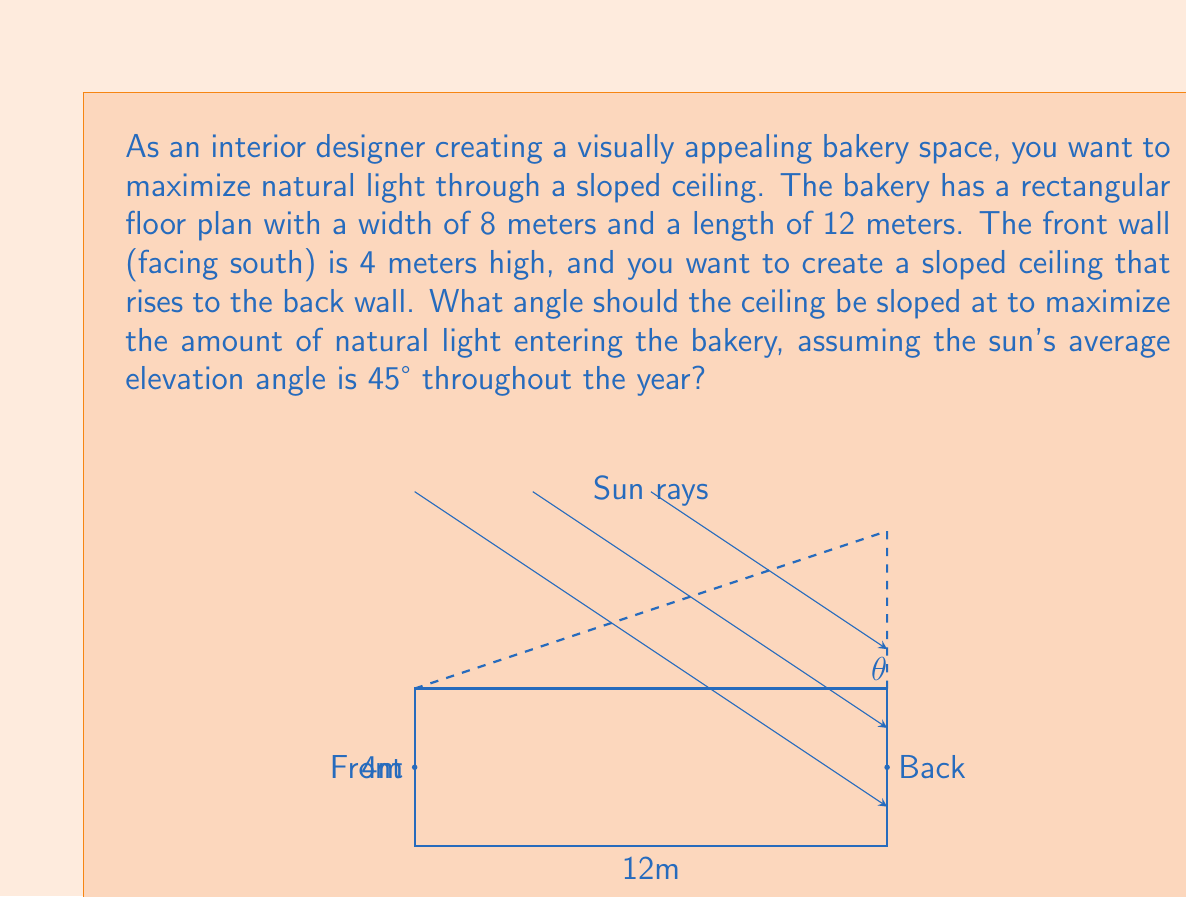Show me your answer to this math problem. To solve this problem, we need to consider the geometry of the bakery and the angle of the incoming sunlight. Let's approach this step-by-step:

1) First, we need to understand that the optimal angle for the ceiling would be perpendicular to the incoming sunlight. This would allow the maximum amount of light to enter the bakery.

2) Given that the sun's average elevation angle is 45°, the optimal ceiling angle would be 90° - 45° = 45° from the horizontal.

3) Now, let's check if this 45° angle is feasible given the bakery's dimensions:

   - The length of the bakery is 12 meters
   - The front wall height is 4 meters
   - Let's call the height of the back wall $h$ meters

4) In a right-angled triangle formed by the ceiling slope:
   
   $\tan(\theta) = \frac{\text{opposite}}{\text{adjacent}} = \frac{h - 4}{12}$

5) For a 45° angle:

   $\tan(45°) = 1 = \frac{h - 4}{12}$

6) Solving for $h$:

   $h - 4 = 12$
   $h = 16$ meters

7) This means the back wall would need to be 16 meters high for a 45° slope, which is likely impractical for a bakery.

8) Instead, let's calculate the actual angle given the practical constraints. Assuming a reasonable back wall height of 8 meters:

   $\tan(\theta) = \frac{8 - 4}{12} = \frac{4}{12} = \frac{1}{3}$

9) To find $\theta$:

   $\theta = \arctan(\frac{1}{3}) \approx 18.43°$

This angle, while not ideal, provides a good balance between maximizing natural light and maintaining a practical ceiling height.
Answer: The optimal angle for the sloped ceiling is approximately $18.43°$ from the horizontal. 